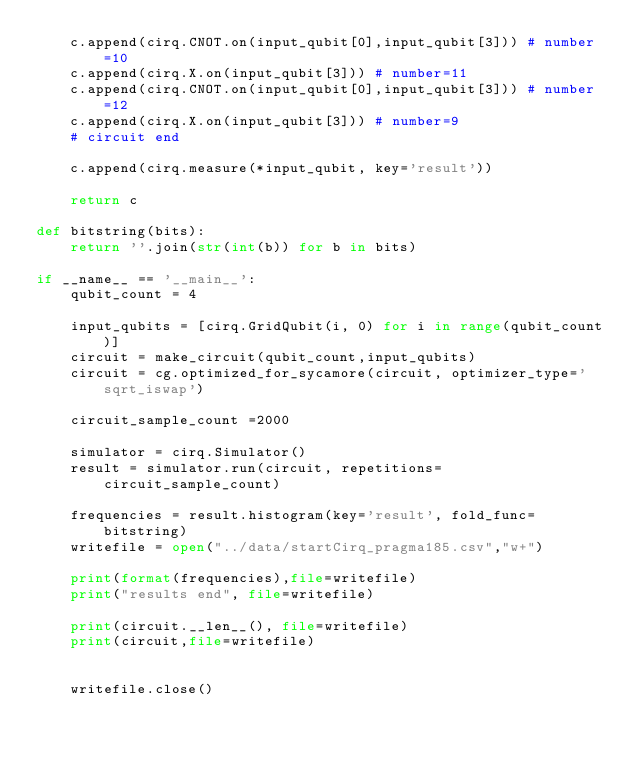Convert code to text. <code><loc_0><loc_0><loc_500><loc_500><_Python_>    c.append(cirq.CNOT.on(input_qubit[0],input_qubit[3])) # number=10
    c.append(cirq.X.on(input_qubit[3])) # number=11
    c.append(cirq.CNOT.on(input_qubit[0],input_qubit[3])) # number=12
    c.append(cirq.X.on(input_qubit[3])) # number=9
    # circuit end

    c.append(cirq.measure(*input_qubit, key='result'))

    return c

def bitstring(bits):
    return ''.join(str(int(b)) for b in bits)

if __name__ == '__main__':
    qubit_count = 4

    input_qubits = [cirq.GridQubit(i, 0) for i in range(qubit_count)]
    circuit = make_circuit(qubit_count,input_qubits)
    circuit = cg.optimized_for_sycamore(circuit, optimizer_type='sqrt_iswap')

    circuit_sample_count =2000

    simulator = cirq.Simulator()
    result = simulator.run(circuit, repetitions=circuit_sample_count)

    frequencies = result.histogram(key='result', fold_func=bitstring)
    writefile = open("../data/startCirq_pragma185.csv","w+")

    print(format(frequencies),file=writefile)
    print("results end", file=writefile)

    print(circuit.__len__(), file=writefile)
    print(circuit,file=writefile)


    writefile.close()</code> 